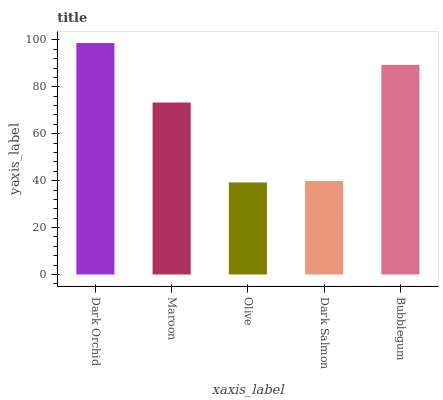Is Maroon the minimum?
Answer yes or no. No. Is Maroon the maximum?
Answer yes or no. No. Is Dark Orchid greater than Maroon?
Answer yes or no. Yes. Is Maroon less than Dark Orchid?
Answer yes or no. Yes. Is Maroon greater than Dark Orchid?
Answer yes or no. No. Is Dark Orchid less than Maroon?
Answer yes or no. No. Is Maroon the high median?
Answer yes or no. Yes. Is Maroon the low median?
Answer yes or no. Yes. Is Bubblegum the high median?
Answer yes or no. No. Is Dark Salmon the low median?
Answer yes or no. No. 